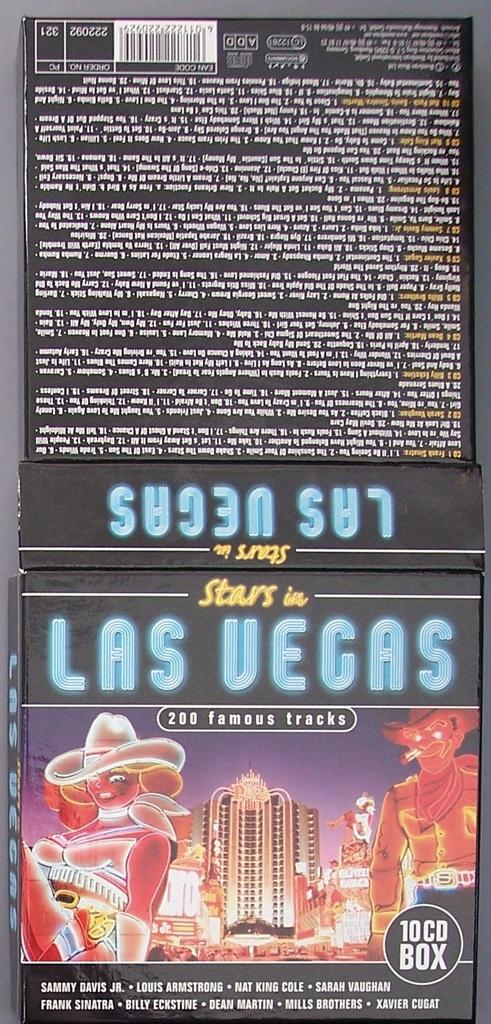Provide a one-sentence caption for the provided image. The 10 CD Box of Stars in Las Vegas includes Sammy Davis Jr., Louis Armstrong, Nat King Cole, and Sarah Vaughan. 